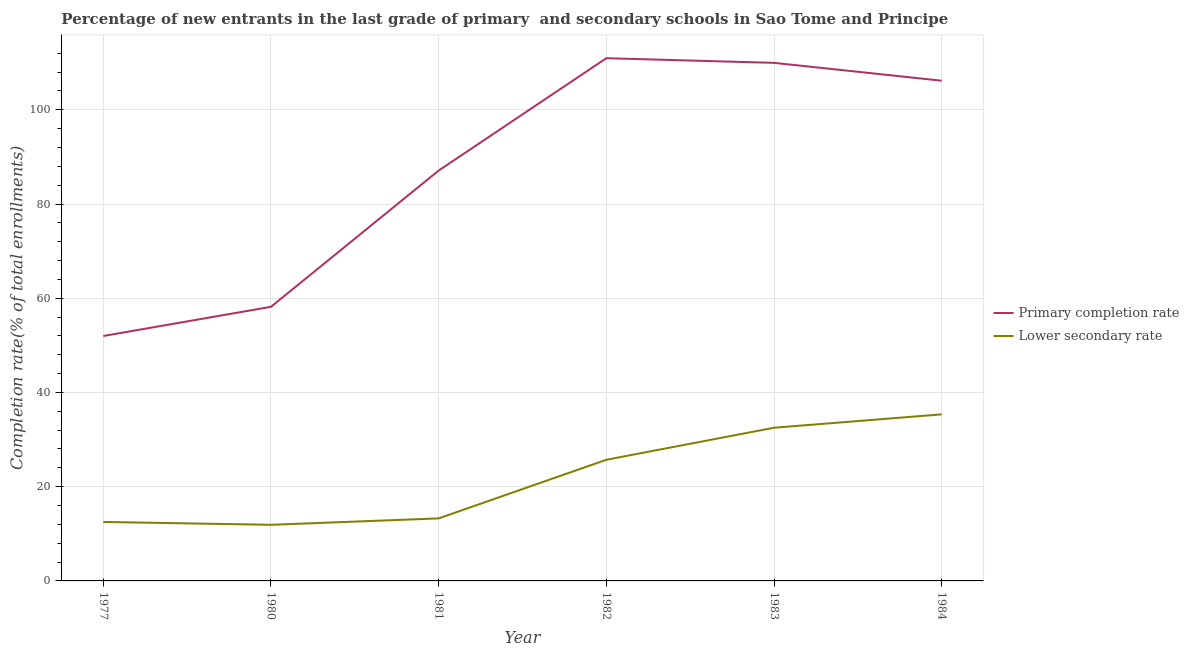What is the completion rate in primary schools in 1981?
Provide a short and direct response. 87.1. Across all years, what is the maximum completion rate in primary schools?
Keep it short and to the point. 110.94. Across all years, what is the minimum completion rate in secondary schools?
Your answer should be very brief. 11.91. In which year was the completion rate in secondary schools maximum?
Ensure brevity in your answer.  1984. What is the total completion rate in primary schools in the graph?
Ensure brevity in your answer.  524.33. What is the difference between the completion rate in primary schools in 1977 and that in 1981?
Your answer should be compact. -35.12. What is the difference between the completion rate in primary schools in 1977 and the completion rate in secondary schools in 1983?
Keep it short and to the point. 19.47. What is the average completion rate in primary schools per year?
Your response must be concise. 87.39. In the year 1981, what is the difference between the completion rate in secondary schools and completion rate in primary schools?
Your answer should be very brief. -73.83. In how many years, is the completion rate in primary schools greater than 64 %?
Your answer should be very brief. 4. What is the ratio of the completion rate in primary schools in 1981 to that in 1984?
Provide a short and direct response. 0.82. Is the difference between the completion rate in primary schools in 1981 and 1982 greater than the difference between the completion rate in secondary schools in 1981 and 1982?
Provide a succinct answer. No. What is the difference between the highest and the second highest completion rate in primary schools?
Provide a short and direct response. 0.99. What is the difference between the highest and the lowest completion rate in secondary schools?
Give a very brief answer. 23.44. In how many years, is the completion rate in primary schools greater than the average completion rate in primary schools taken over all years?
Make the answer very short. 3. Is the sum of the completion rate in primary schools in 1977 and 1980 greater than the maximum completion rate in secondary schools across all years?
Your response must be concise. Yes. Does the completion rate in primary schools monotonically increase over the years?
Provide a succinct answer. No. Is the completion rate in primary schools strictly greater than the completion rate in secondary schools over the years?
Keep it short and to the point. Yes. Is the completion rate in secondary schools strictly less than the completion rate in primary schools over the years?
Provide a short and direct response. Yes. How many years are there in the graph?
Ensure brevity in your answer.  6. What is the difference between two consecutive major ticks on the Y-axis?
Offer a terse response. 20. Are the values on the major ticks of Y-axis written in scientific E-notation?
Offer a very short reply. No. Where does the legend appear in the graph?
Your answer should be compact. Center right. What is the title of the graph?
Your answer should be very brief. Percentage of new entrants in the last grade of primary  and secondary schools in Sao Tome and Principe. Does "By country of origin" appear as one of the legend labels in the graph?
Offer a terse response. No. What is the label or title of the X-axis?
Your answer should be compact. Year. What is the label or title of the Y-axis?
Keep it short and to the point. Completion rate(% of total enrollments). What is the Completion rate(% of total enrollments) in Primary completion rate in 1977?
Give a very brief answer. 51.98. What is the Completion rate(% of total enrollments) of Lower secondary rate in 1977?
Keep it short and to the point. 12.52. What is the Completion rate(% of total enrollments) of Primary completion rate in 1980?
Provide a short and direct response. 58.18. What is the Completion rate(% of total enrollments) of Lower secondary rate in 1980?
Provide a succinct answer. 11.91. What is the Completion rate(% of total enrollments) of Primary completion rate in 1981?
Provide a short and direct response. 87.1. What is the Completion rate(% of total enrollments) of Lower secondary rate in 1981?
Your response must be concise. 13.27. What is the Completion rate(% of total enrollments) of Primary completion rate in 1982?
Make the answer very short. 110.94. What is the Completion rate(% of total enrollments) in Lower secondary rate in 1982?
Ensure brevity in your answer.  25.71. What is the Completion rate(% of total enrollments) in Primary completion rate in 1983?
Keep it short and to the point. 109.96. What is the Completion rate(% of total enrollments) in Lower secondary rate in 1983?
Your answer should be very brief. 32.51. What is the Completion rate(% of total enrollments) in Primary completion rate in 1984?
Keep it short and to the point. 106.17. What is the Completion rate(% of total enrollments) in Lower secondary rate in 1984?
Ensure brevity in your answer.  35.35. Across all years, what is the maximum Completion rate(% of total enrollments) in Primary completion rate?
Your response must be concise. 110.94. Across all years, what is the maximum Completion rate(% of total enrollments) of Lower secondary rate?
Ensure brevity in your answer.  35.35. Across all years, what is the minimum Completion rate(% of total enrollments) of Primary completion rate?
Your response must be concise. 51.98. Across all years, what is the minimum Completion rate(% of total enrollments) of Lower secondary rate?
Your response must be concise. 11.91. What is the total Completion rate(% of total enrollments) in Primary completion rate in the graph?
Your answer should be compact. 524.33. What is the total Completion rate(% of total enrollments) of Lower secondary rate in the graph?
Provide a succinct answer. 131.28. What is the difference between the Completion rate(% of total enrollments) in Primary completion rate in 1977 and that in 1980?
Offer a terse response. -6.2. What is the difference between the Completion rate(% of total enrollments) of Lower secondary rate in 1977 and that in 1980?
Your answer should be compact. 0.61. What is the difference between the Completion rate(% of total enrollments) of Primary completion rate in 1977 and that in 1981?
Keep it short and to the point. -35.12. What is the difference between the Completion rate(% of total enrollments) of Lower secondary rate in 1977 and that in 1981?
Give a very brief answer. -0.75. What is the difference between the Completion rate(% of total enrollments) of Primary completion rate in 1977 and that in 1982?
Provide a succinct answer. -58.96. What is the difference between the Completion rate(% of total enrollments) of Lower secondary rate in 1977 and that in 1982?
Offer a terse response. -13.19. What is the difference between the Completion rate(% of total enrollments) of Primary completion rate in 1977 and that in 1983?
Offer a very short reply. -57.98. What is the difference between the Completion rate(% of total enrollments) of Lower secondary rate in 1977 and that in 1983?
Your answer should be very brief. -19.99. What is the difference between the Completion rate(% of total enrollments) in Primary completion rate in 1977 and that in 1984?
Provide a succinct answer. -54.19. What is the difference between the Completion rate(% of total enrollments) of Lower secondary rate in 1977 and that in 1984?
Your answer should be very brief. -22.83. What is the difference between the Completion rate(% of total enrollments) in Primary completion rate in 1980 and that in 1981?
Provide a succinct answer. -28.92. What is the difference between the Completion rate(% of total enrollments) in Lower secondary rate in 1980 and that in 1981?
Your answer should be compact. -1.36. What is the difference between the Completion rate(% of total enrollments) of Primary completion rate in 1980 and that in 1982?
Your response must be concise. -52.77. What is the difference between the Completion rate(% of total enrollments) in Lower secondary rate in 1980 and that in 1982?
Your answer should be very brief. -13.8. What is the difference between the Completion rate(% of total enrollments) of Primary completion rate in 1980 and that in 1983?
Keep it short and to the point. -51.78. What is the difference between the Completion rate(% of total enrollments) of Lower secondary rate in 1980 and that in 1983?
Provide a succinct answer. -20.6. What is the difference between the Completion rate(% of total enrollments) in Primary completion rate in 1980 and that in 1984?
Provide a short and direct response. -47.99. What is the difference between the Completion rate(% of total enrollments) in Lower secondary rate in 1980 and that in 1984?
Offer a terse response. -23.44. What is the difference between the Completion rate(% of total enrollments) in Primary completion rate in 1981 and that in 1982?
Give a very brief answer. -23.85. What is the difference between the Completion rate(% of total enrollments) of Lower secondary rate in 1981 and that in 1982?
Keep it short and to the point. -12.44. What is the difference between the Completion rate(% of total enrollments) of Primary completion rate in 1981 and that in 1983?
Your response must be concise. -22.86. What is the difference between the Completion rate(% of total enrollments) of Lower secondary rate in 1981 and that in 1983?
Keep it short and to the point. -19.24. What is the difference between the Completion rate(% of total enrollments) of Primary completion rate in 1981 and that in 1984?
Ensure brevity in your answer.  -19.07. What is the difference between the Completion rate(% of total enrollments) of Lower secondary rate in 1981 and that in 1984?
Ensure brevity in your answer.  -22.08. What is the difference between the Completion rate(% of total enrollments) of Primary completion rate in 1982 and that in 1983?
Provide a succinct answer. 0.99. What is the difference between the Completion rate(% of total enrollments) of Lower secondary rate in 1982 and that in 1983?
Provide a short and direct response. -6.8. What is the difference between the Completion rate(% of total enrollments) of Primary completion rate in 1982 and that in 1984?
Your response must be concise. 4.78. What is the difference between the Completion rate(% of total enrollments) of Lower secondary rate in 1982 and that in 1984?
Your answer should be compact. -9.64. What is the difference between the Completion rate(% of total enrollments) of Primary completion rate in 1983 and that in 1984?
Your response must be concise. 3.79. What is the difference between the Completion rate(% of total enrollments) in Lower secondary rate in 1983 and that in 1984?
Your answer should be compact. -2.84. What is the difference between the Completion rate(% of total enrollments) in Primary completion rate in 1977 and the Completion rate(% of total enrollments) in Lower secondary rate in 1980?
Provide a short and direct response. 40.07. What is the difference between the Completion rate(% of total enrollments) in Primary completion rate in 1977 and the Completion rate(% of total enrollments) in Lower secondary rate in 1981?
Your answer should be very brief. 38.71. What is the difference between the Completion rate(% of total enrollments) of Primary completion rate in 1977 and the Completion rate(% of total enrollments) of Lower secondary rate in 1982?
Keep it short and to the point. 26.27. What is the difference between the Completion rate(% of total enrollments) of Primary completion rate in 1977 and the Completion rate(% of total enrollments) of Lower secondary rate in 1983?
Offer a very short reply. 19.47. What is the difference between the Completion rate(% of total enrollments) of Primary completion rate in 1977 and the Completion rate(% of total enrollments) of Lower secondary rate in 1984?
Offer a terse response. 16.63. What is the difference between the Completion rate(% of total enrollments) of Primary completion rate in 1980 and the Completion rate(% of total enrollments) of Lower secondary rate in 1981?
Ensure brevity in your answer.  44.91. What is the difference between the Completion rate(% of total enrollments) of Primary completion rate in 1980 and the Completion rate(% of total enrollments) of Lower secondary rate in 1982?
Your answer should be compact. 32.47. What is the difference between the Completion rate(% of total enrollments) of Primary completion rate in 1980 and the Completion rate(% of total enrollments) of Lower secondary rate in 1983?
Ensure brevity in your answer.  25.67. What is the difference between the Completion rate(% of total enrollments) of Primary completion rate in 1980 and the Completion rate(% of total enrollments) of Lower secondary rate in 1984?
Offer a terse response. 22.83. What is the difference between the Completion rate(% of total enrollments) in Primary completion rate in 1981 and the Completion rate(% of total enrollments) in Lower secondary rate in 1982?
Your response must be concise. 61.38. What is the difference between the Completion rate(% of total enrollments) in Primary completion rate in 1981 and the Completion rate(% of total enrollments) in Lower secondary rate in 1983?
Make the answer very short. 54.59. What is the difference between the Completion rate(% of total enrollments) of Primary completion rate in 1981 and the Completion rate(% of total enrollments) of Lower secondary rate in 1984?
Give a very brief answer. 51.75. What is the difference between the Completion rate(% of total enrollments) in Primary completion rate in 1982 and the Completion rate(% of total enrollments) in Lower secondary rate in 1983?
Make the answer very short. 78.43. What is the difference between the Completion rate(% of total enrollments) of Primary completion rate in 1982 and the Completion rate(% of total enrollments) of Lower secondary rate in 1984?
Ensure brevity in your answer.  75.59. What is the difference between the Completion rate(% of total enrollments) of Primary completion rate in 1983 and the Completion rate(% of total enrollments) of Lower secondary rate in 1984?
Offer a terse response. 74.61. What is the average Completion rate(% of total enrollments) of Primary completion rate per year?
Your response must be concise. 87.39. What is the average Completion rate(% of total enrollments) of Lower secondary rate per year?
Make the answer very short. 21.88. In the year 1977, what is the difference between the Completion rate(% of total enrollments) of Primary completion rate and Completion rate(% of total enrollments) of Lower secondary rate?
Your answer should be very brief. 39.46. In the year 1980, what is the difference between the Completion rate(% of total enrollments) in Primary completion rate and Completion rate(% of total enrollments) in Lower secondary rate?
Your response must be concise. 46.27. In the year 1981, what is the difference between the Completion rate(% of total enrollments) of Primary completion rate and Completion rate(% of total enrollments) of Lower secondary rate?
Keep it short and to the point. 73.83. In the year 1982, what is the difference between the Completion rate(% of total enrollments) of Primary completion rate and Completion rate(% of total enrollments) of Lower secondary rate?
Provide a succinct answer. 85.23. In the year 1983, what is the difference between the Completion rate(% of total enrollments) in Primary completion rate and Completion rate(% of total enrollments) in Lower secondary rate?
Offer a very short reply. 77.45. In the year 1984, what is the difference between the Completion rate(% of total enrollments) in Primary completion rate and Completion rate(% of total enrollments) in Lower secondary rate?
Ensure brevity in your answer.  70.82. What is the ratio of the Completion rate(% of total enrollments) of Primary completion rate in 1977 to that in 1980?
Give a very brief answer. 0.89. What is the ratio of the Completion rate(% of total enrollments) in Lower secondary rate in 1977 to that in 1980?
Your answer should be compact. 1.05. What is the ratio of the Completion rate(% of total enrollments) in Primary completion rate in 1977 to that in 1981?
Your response must be concise. 0.6. What is the ratio of the Completion rate(% of total enrollments) in Lower secondary rate in 1977 to that in 1981?
Offer a terse response. 0.94. What is the ratio of the Completion rate(% of total enrollments) of Primary completion rate in 1977 to that in 1982?
Provide a succinct answer. 0.47. What is the ratio of the Completion rate(% of total enrollments) of Lower secondary rate in 1977 to that in 1982?
Make the answer very short. 0.49. What is the ratio of the Completion rate(% of total enrollments) of Primary completion rate in 1977 to that in 1983?
Your answer should be compact. 0.47. What is the ratio of the Completion rate(% of total enrollments) in Lower secondary rate in 1977 to that in 1983?
Provide a succinct answer. 0.39. What is the ratio of the Completion rate(% of total enrollments) of Primary completion rate in 1977 to that in 1984?
Offer a very short reply. 0.49. What is the ratio of the Completion rate(% of total enrollments) in Lower secondary rate in 1977 to that in 1984?
Give a very brief answer. 0.35. What is the ratio of the Completion rate(% of total enrollments) of Primary completion rate in 1980 to that in 1981?
Offer a very short reply. 0.67. What is the ratio of the Completion rate(% of total enrollments) in Lower secondary rate in 1980 to that in 1981?
Your answer should be compact. 0.9. What is the ratio of the Completion rate(% of total enrollments) in Primary completion rate in 1980 to that in 1982?
Offer a very short reply. 0.52. What is the ratio of the Completion rate(% of total enrollments) of Lower secondary rate in 1980 to that in 1982?
Your answer should be compact. 0.46. What is the ratio of the Completion rate(% of total enrollments) of Primary completion rate in 1980 to that in 1983?
Provide a short and direct response. 0.53. What is the ratio of the Completion rate(% of total enrollments) in Lower secondary rate in 1980 to that in 1983?
Your response must be concise. 0.37. What is the ratio of the Completion rate(% of total enrollments) of Primary completion rate in 1980 to that in 1984?
Your response must be concise. 0.55. What is the ratio of the Completion rate(% of total enrollments) of Lower secondary rate in 1980 to that in 1984?
Give a very brief answer. 0.34. What is the ratio of the Completion rate(% of total enrollments) in Primary completion rate in 1981 to that in 1982?
Your answer should be very brief. 0.79. What is the ratio of the Completion rate(% of total enrollments) of Lower secondary rate in 1981 to that in 1982?
Your answer should be compact. 0.52. What is the ratio of the Completion rate(% of total enrollments) in Primary completion rate in 1981 to that in 1983?
Provide a succinct answer. 0.79. What is the ratio of the Completion rate(% of total enrollments) in Lower secondary rate in 1981 to that in 1983?
Give a very brief answer. 0.41. What is the ratio of the Completion rate(% of total enrollments) of Primary completion rate in 1981 to that in 1984?
Provide a short and direct response. 0.82. What is the ratio of the Completion rate(% of total enrollments) of Lower secondary rate in 1981 to that in 1984?
Keep it short and to the point. 0.38. What is the ratio of the Completion rate(% of total enrollments) in Primary completion rate in 1982 to that in 1983?
Keep it short and to the point. 1.01. What is the ratio of the Completion rate(% of total enrollments) in Lower secondary rate in 1982 to that in 1983?
Your answer should be compact. 0.79. What is the ratio of the Completion rate(% of total enrollments) of Primary completion rate in 1982 to that in 1984?
Your response must be concise. 1.04. What is the ratio of the Completion rate(% of total enrollments) in Lower secondary rate in 1982 to that in 1984?
Provide a short and direct response. 0.73. What is the ratio of the Completion rate(% of total enrollments) in Primary completion rate in 1983 to that in 1984?
Offer a very short reply. 1.04. What is the ratio of the Completion rate(% of total enrollments) in Lower secondary rate in 1983 to that in 1984?
Give a very brief answer. 0.92. What is the difference between the highest and the second highest Completion rate(% of total enrollments) in Primary completion rate?
Keep it short and to the point. 0.99. What is the difference between the highest and the second highest Completion rate(% of total enrollments) in Lower secondary rate?
Your response must be concise. 2.84. What is the difference between the highest and the lowest Completion rate(% of total enrollments) in Primary completion rate?
Provide a succinct answer. 58.96. What is the difference between the highest and the lowest Completion rate(% of total enrollments) in Lower secondary rate?
Give a very brief answer. 23.44. 